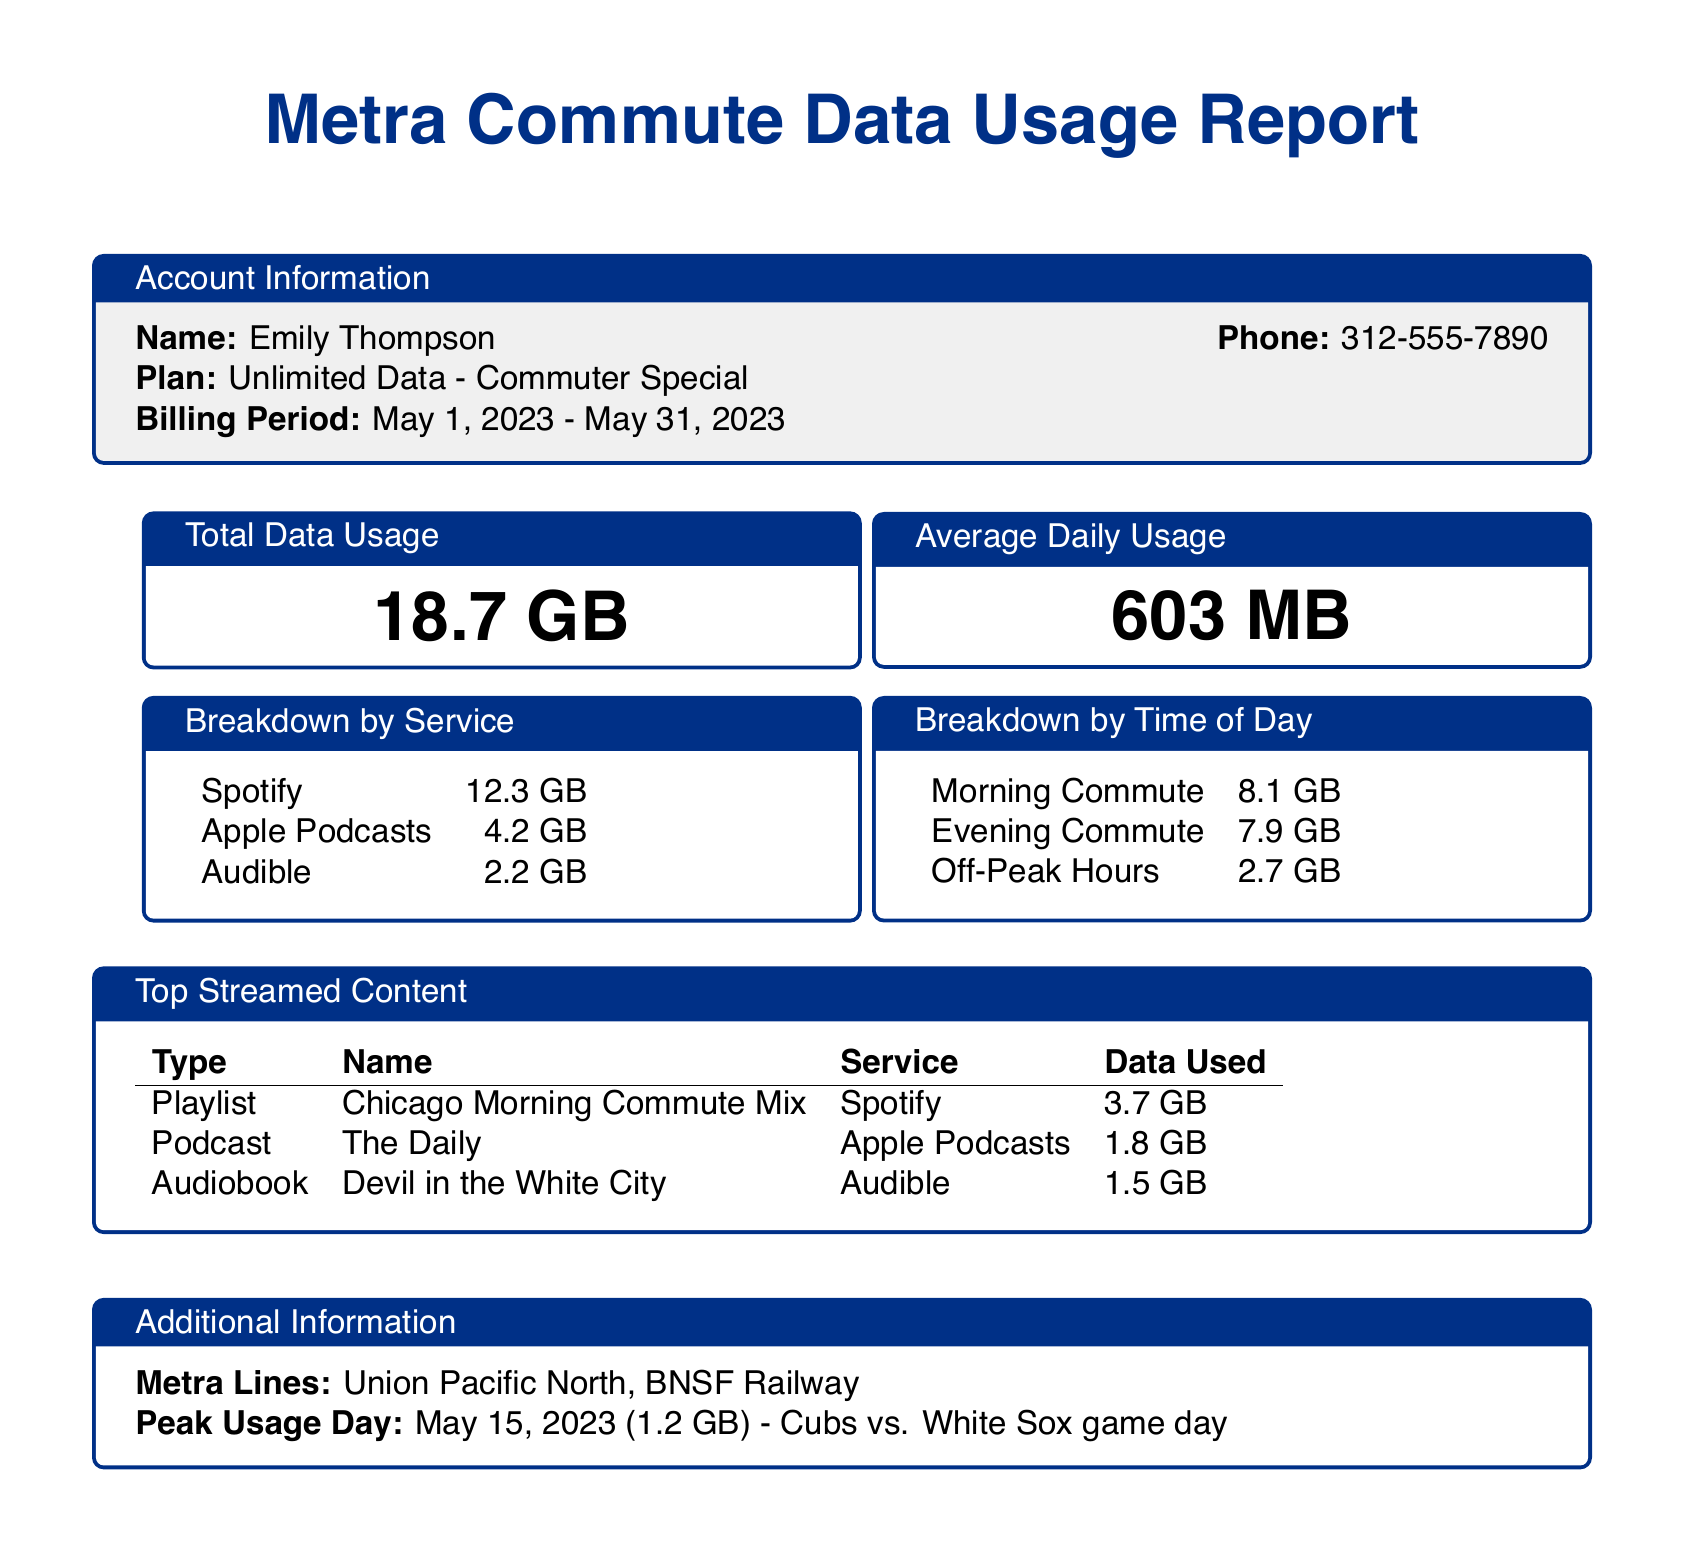What is the total data usage for May? The total data usage is stated clearly in the document as 18.7 GB for the billing period.
Answer: 18.7 GB What was the average daily usage? The document specifies the average daily usage as calculated over the month, which is 603 MB.
Answer: 603 MB How much data was used for Spotify? The breakdown by service shows that Spotify usage was 12.3 GB.
Answer: 12.3 GB What time period had the highest data usage? By comparing the time of day breakdowns, the morning commute had the highest usage at 8.1 GB.
Answer: Morning Commute Which podcast consumed 1.8 GB of data? The top streamed content table lists "The Daily" as the podcast that used 1.8 GB.
Answer: The Daily What was the peak usage day in May? The document identifies May 15, 2023, as the peak usage day, notably indicated due to a special event.
Answer: May 15, 2023 How much data was consumed during off-peak hours? The breakdown by time of day shows that off-peak hours accounted for 2.7 GB of data usage.
Answer: 2.7 GB What plan does Emily Thompson have? The account information section clearly states that she is on the "Unlimited Data - Commuter Special" plan.
Answer: Unlimited Data - Commuter Special 